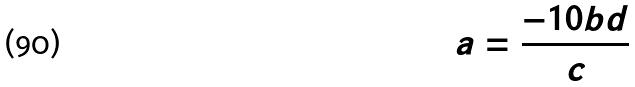<formula> <loc_0><loc_0><loc_500><loc_500>a = \frac { - 1 0 b d } { c }</formula> 